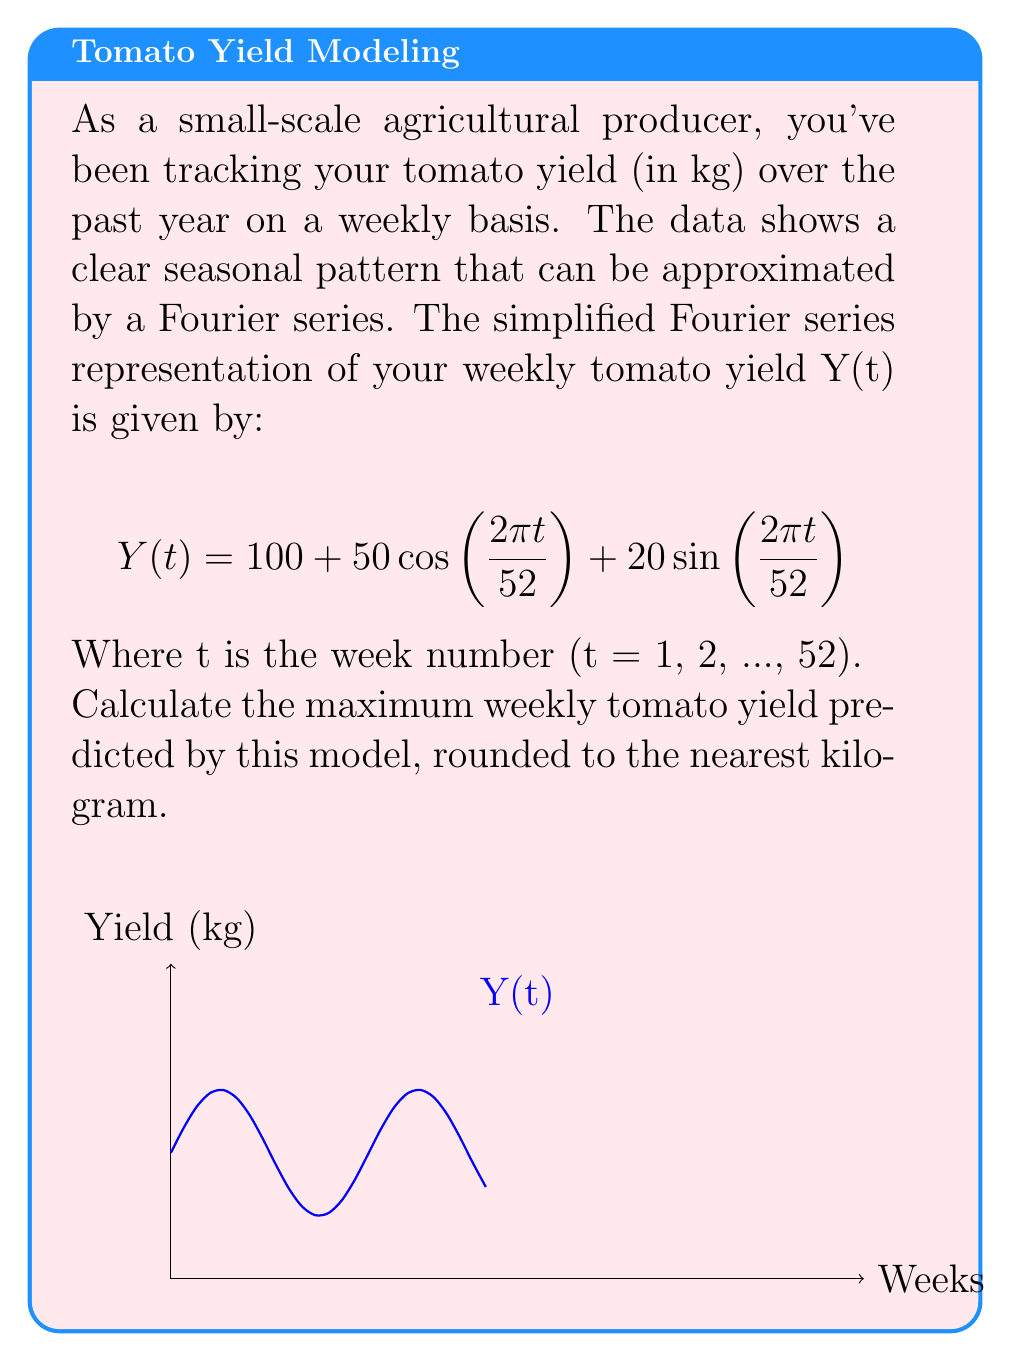Provide a solution to this math problem. To find the maximum yield, we need to follow these steps:

1) The general form of our Fourier series is:
   $$Y(t) = A_0 + A_1\cos(\omega t) + B_1\sin(\omega t)$$
   Where $A_0 = 100$, $A_1 = 50$, $B_1 = 20$, and $\omega = \frac{2\pi}{52}$

2) The maximum of this function occurs when the cosine and sine terms are at their peak simultaneously. This happens when:
   $$\cos(\omega t) = \cos(\phi)$$ and $$\sin(\omega t) = \sin(\phi)$$
   Where $\phi = \arctan(\frac{B_1}{A_1}) = \arctan(\frac{20}{50})$

3) At this point, the maximum value is:
   $$Y_{max} = A_0 + \sqrt{A_1^2 + B_1^2}$$

4) Let's calculate:
   $$Y_{max} = 100 + \sqrt{50^2 + 20^2}$$
   $$Y_{max} = 100 + \sqrt{2500 + 400}$$
   $$Y_{max} = 100 + \sqrt{2900}$$
   $$Y_{max} = 100 + 53.85$$
   $$Y_{max} = 153.85$$

5) Rounding to the nearest kilogram:
   $$Y_{max} \approx 154 \text{ kg}$$
Answer: 154 kg 